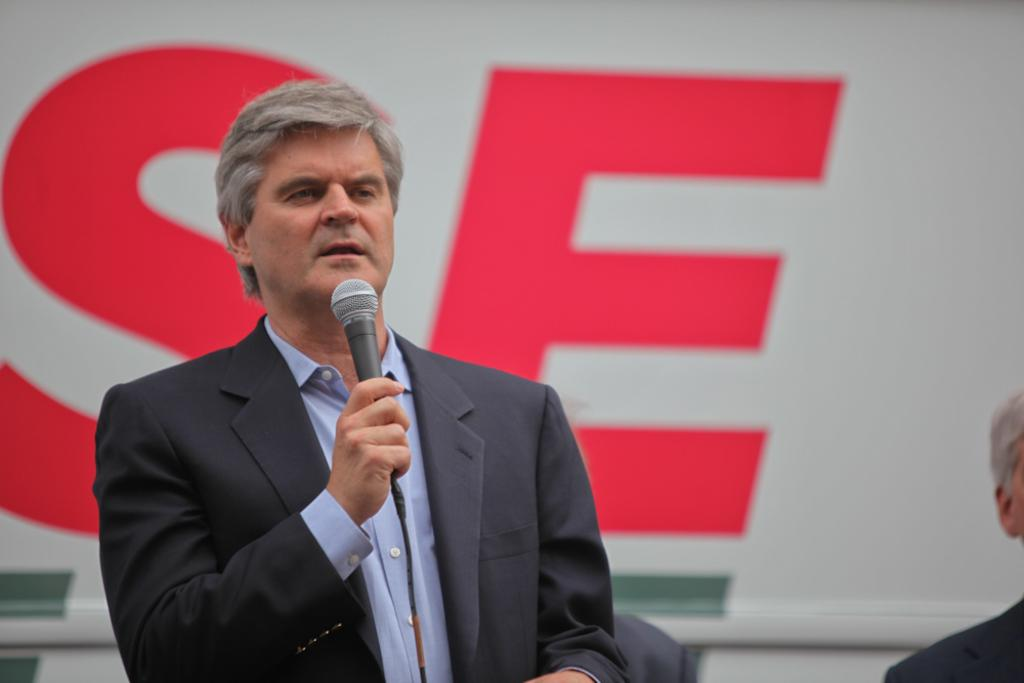What is the man in the image holding? The man is holding a mic in the image. Can you describe the other person in the image? There is another man in the image, and he is wearing a suit. What might the man holding the mic be doing? The man holding the mic might be giving a speech or performing. What type of cow can be seen in the image? There is no cow present in the image. How many crates are visible in the image? There are no crates visible in the image. 